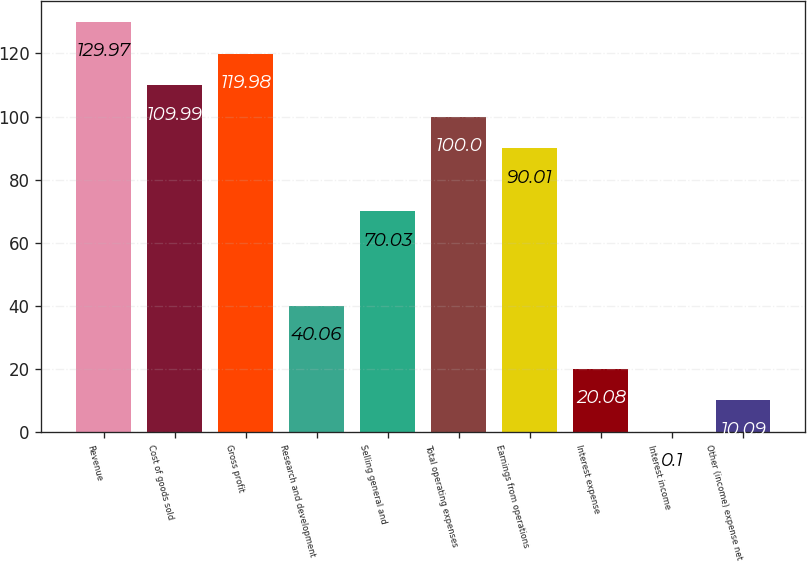<chart> <loc_0><loc_0><loc_500><loc_500><bar_chart><fcel>Revenue<fcel>Cost of goods sold<fcel>Gross profit<fcel>Research and development<fcel>Selling general and<fcel>Total operating expenses<fcel>Earnings from operations<fcel>Interest expense<fcel>Interest income<fcel>Other (income) expense net<nl><fcel>129.97<fcel>109.99<fcel>119.98<fcel>40.06<fcel>70.03<fcel>100<fcel>90.01<fcel>20.08<fcel>0.1<fcel>10.09<nl></chart> 